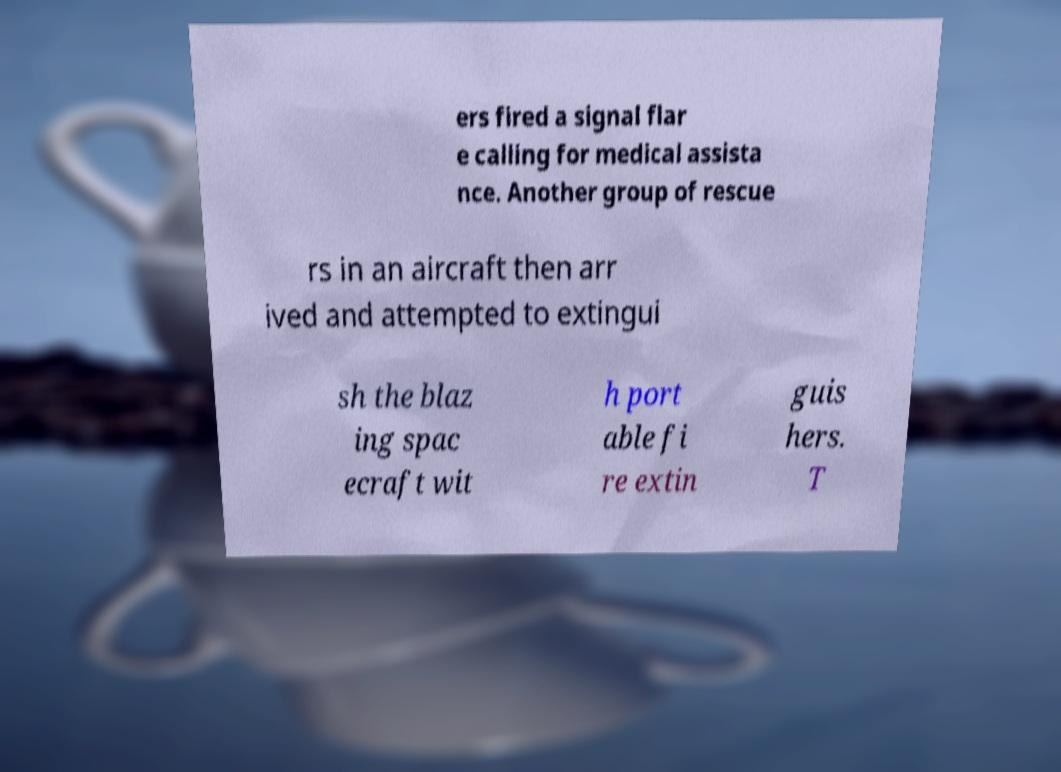There's text embedded in this image that I need extracted. Can you transcribe it verbatim? ers fired a signal flar e calling for medical assista nce. Another group of rescue rs in an aircraft then arr ived and attempted to extingui sh the blaz ing spac ecraft wit h port able fi re extin guis hers. T 